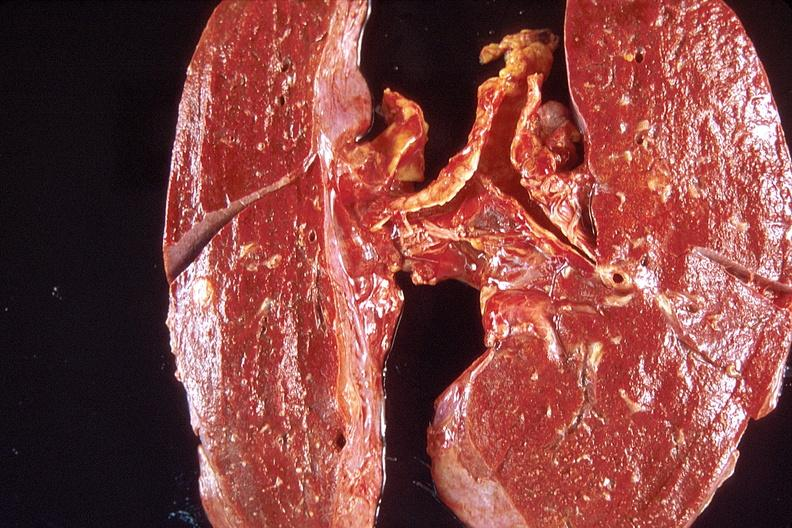what is present?
Answer the question using a single word or phrase. Respiratory 